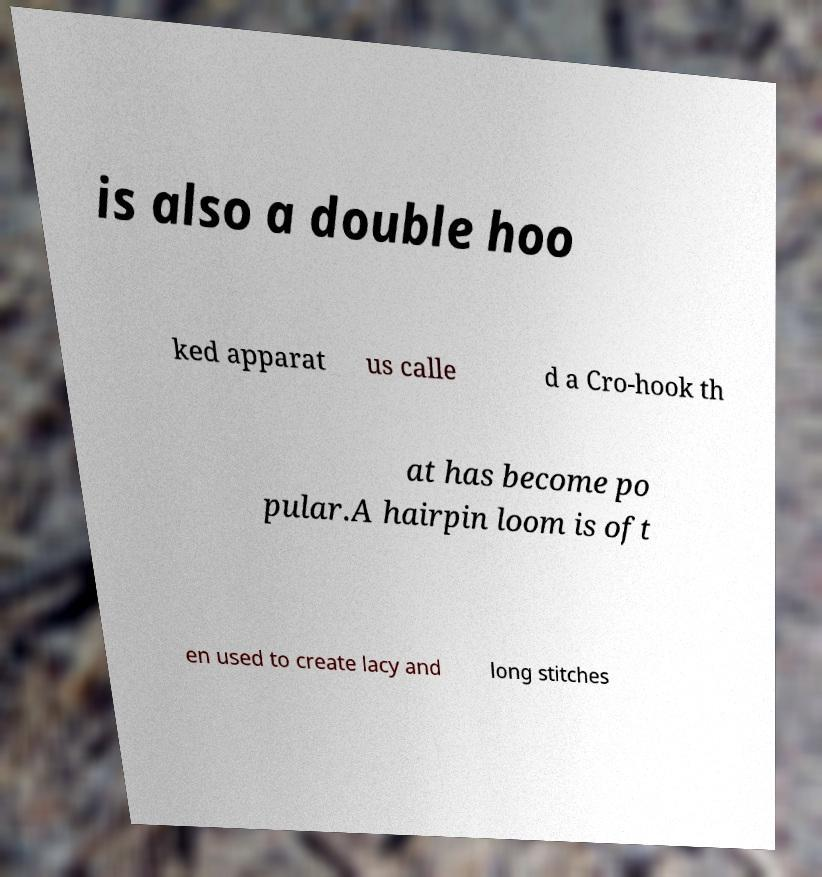Could you assist in decoding the text presented in this image and type it out clearly? is also a double hoo ked apparat us calle d a Cro-hook th at has become po pular.A hairpin loom is oft en used to create lacy and long stitches 